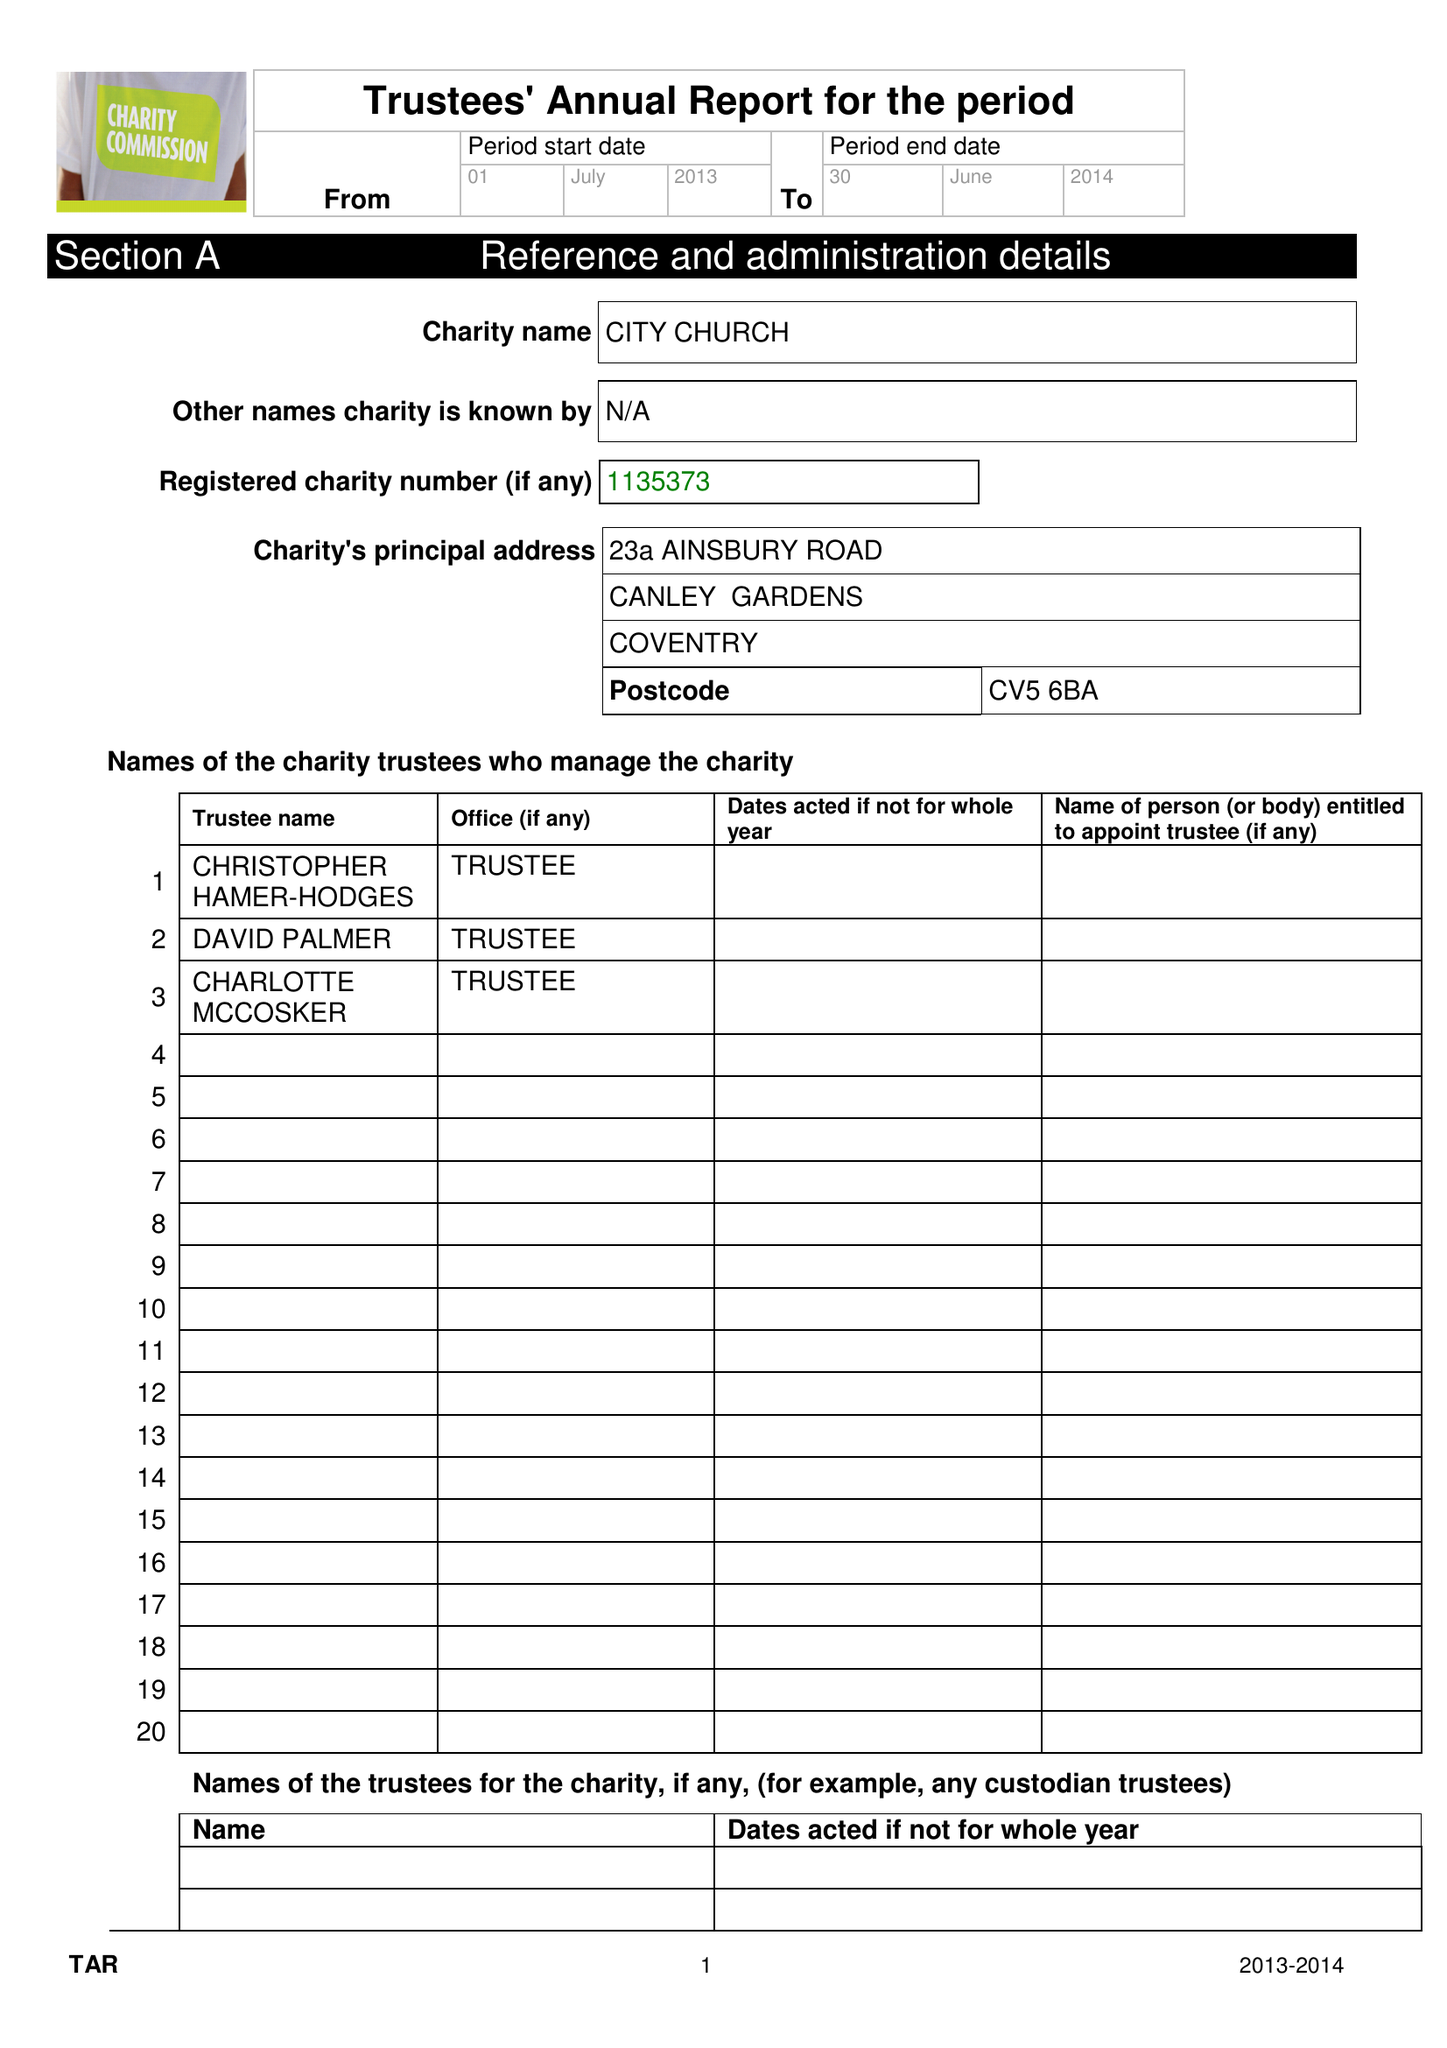What is the value for the address__postcode?
Answer the question using a single word or phrase. CV5 6BA 